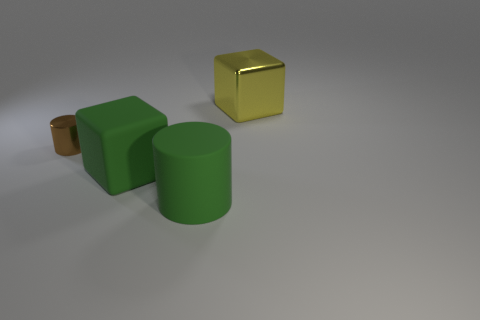Add 4 big yellow metallic balls. How many objects exist? 8 Subtract all large green objects. Subtract all big green things. How many objects are left? 0 Add 4 yellow things. How many yellow things are left? 5 Add 4 big yellow spheres. How many big yellow spheres exist? 4 Subtract 0 brown balls. How many objects are left? 4 